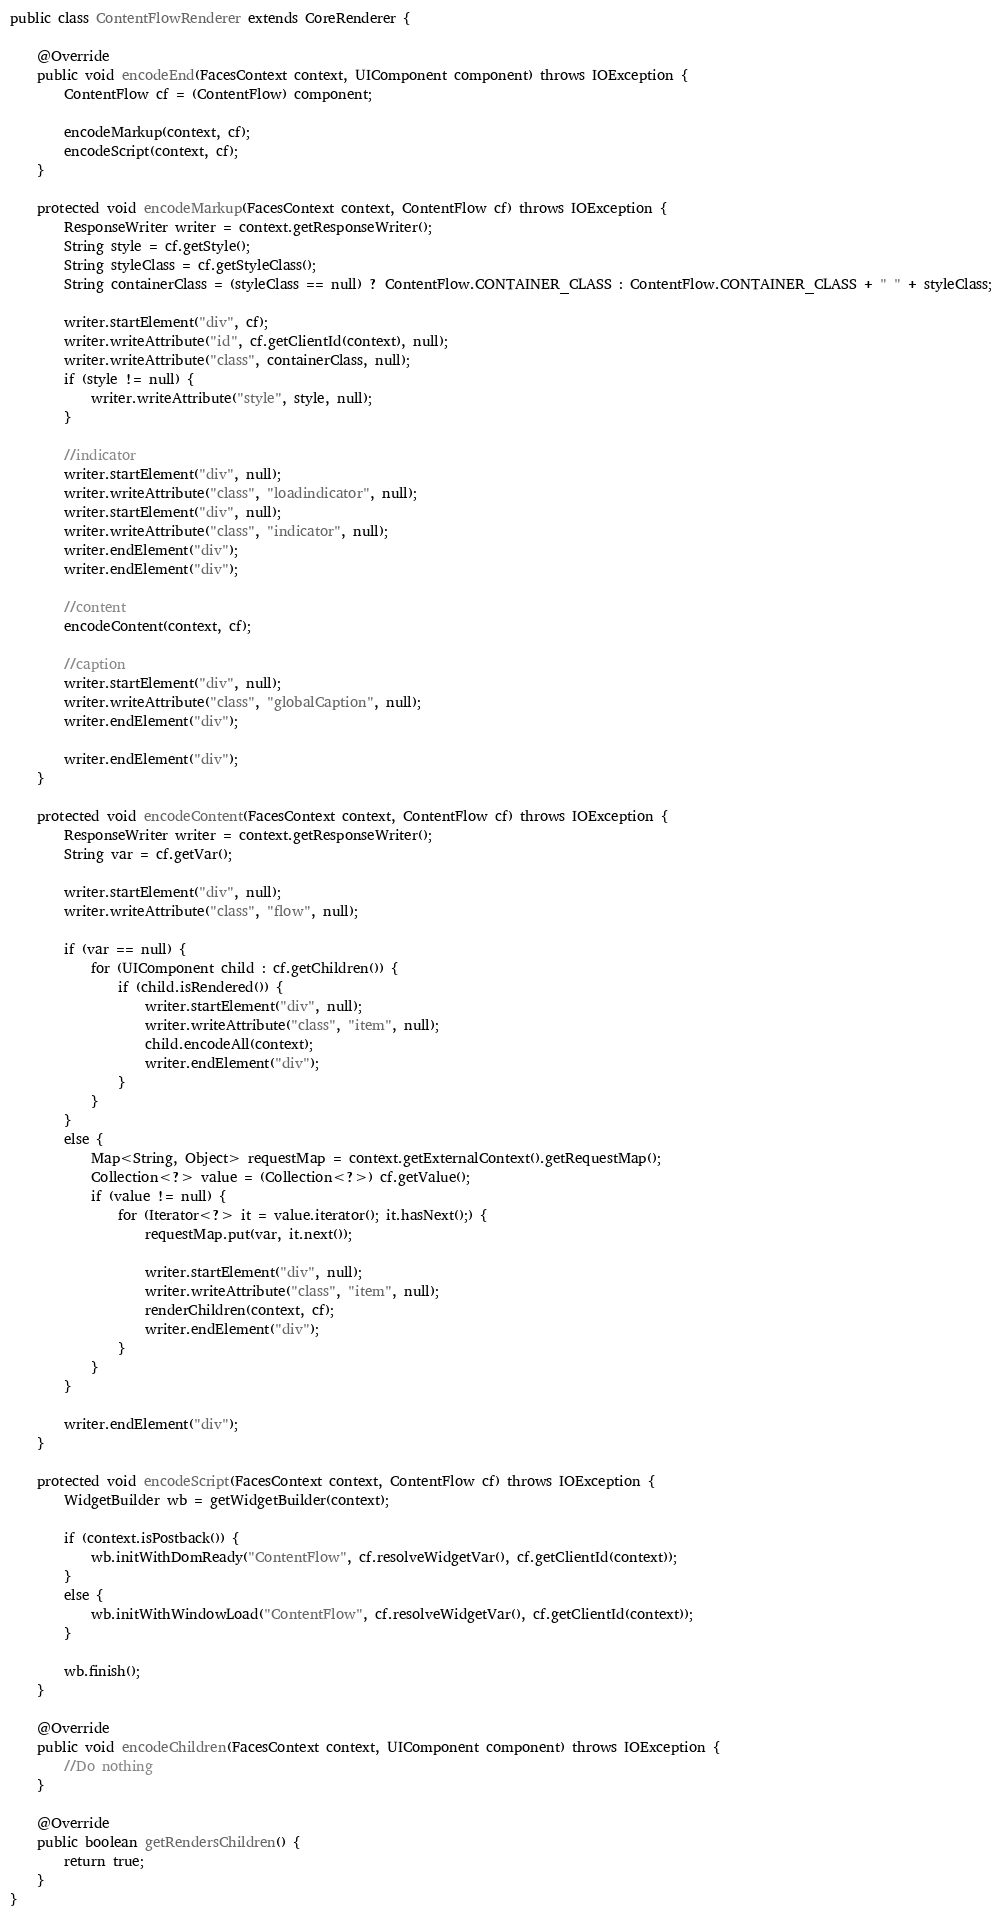<code> <loc_0><loc_0><loc_500><loc_500><_Java_>
public class ContentFlowRenderer extends CoreRenderer {

    @Override
    public void encodeEnd(FacesContext context, UIComponent component) throws IOException {
        ContentFlow cf = (ContentFlow) component;

        encodeMarkup(context, cf);
        encodeScript(context, cf);
    }

    protected void encodeMarkup(FacesContext context, ContentFlow cf) throws IOException {
        ResponseWriter writer = context.getResponseWriter();
        String style = cf.getStyle();
        String styleClass = cf.getStyleClass();
        String containerClass = (styleClass == null) ? ContentFlow.CONTAINER_CLASS : ContentFlow.CONTAINER_CLASS + " " + styleClass;

        writer.startElement("div", cf);
        writer.writeAttribute("id", cf.getClientId(context), null);
        writer.writeAttribute("class", containerClass, null);
        if (style != null) {
            writer.writeAttribute("style", style, null);
        }

        //indicator
        writer.startElement("div", null);
        writer.writeAttribute("class", "loadindicator", null);
        writer.startElement("div", null);
        writer.writeAttribute("class", "indicator", null);
        writer.endElement("div");
        writer.endElement("div");

        //content
        encodeContent(context, cf);

        //caption
        writer.startElement("div", null);
        writer.writeAttribute("class", "globalCaption", null);
        writer.endElement("div");

        writer.endElement("div");
    }

    protected void encodeContent(FacesContext context, ContentFlow cf) throws IOException {
        ResponseWriter writer = context.getResponseWriter();
        String var = cf.getVar();

        writer.startElement("div", null);
        writer.writeAttribute("class", "flow", null);

        if (var == null) {
            for (UIComponent child : cf.getChildren()) {
                if (child.isRendered()) {
                    writer.startElement("div", null);
                    writer.writeAttribute("class", "item", null);
                    child.encodeAll(context);
                    writer.endElement("div");
                }
            }
        }
        else {
            Map<String, Object> requestMap = context.getExternalContext().getRequestMap();
            Collection<?> value = (Collection<?>) cf.getValue();
            if (value != null) {
                for (Iterator<?> it = value.iterator(); it.hasNext();) {
                    requestMap.put(var, it.next());

                    writer.startElement("div", null);
                    writer.writeAttribute("class", "item", null);
                    renderChildren(context, cf);
                    writer.endElement("div");
                }
            }
        }

        writer.endElement("div");
    }

    protected void encodeScript(FacesContext context, ContentFlow cf) throws IOException {
        WidgetBuilder wb = getWidgetBuilder(context);

        if (context.isPostback()) {
            wb.initWithDomReady("ContentFlow", cf.resolveWidgetVar(), cf.getClientId(context));
        }
        else {
            wb.initWithWindowLoad("ContentFlow", cf.resolveWidgetVar(), cf.getClientId(context));
        }

        wb.finish();
    }

    @Override
    public void encodeChildren(FacesContext context, UIComponent component) throws IOException {
        //Do nothing
    }

    @Override
    public boolean getRendersChildren() {
        return true;
    }
}
</code> 